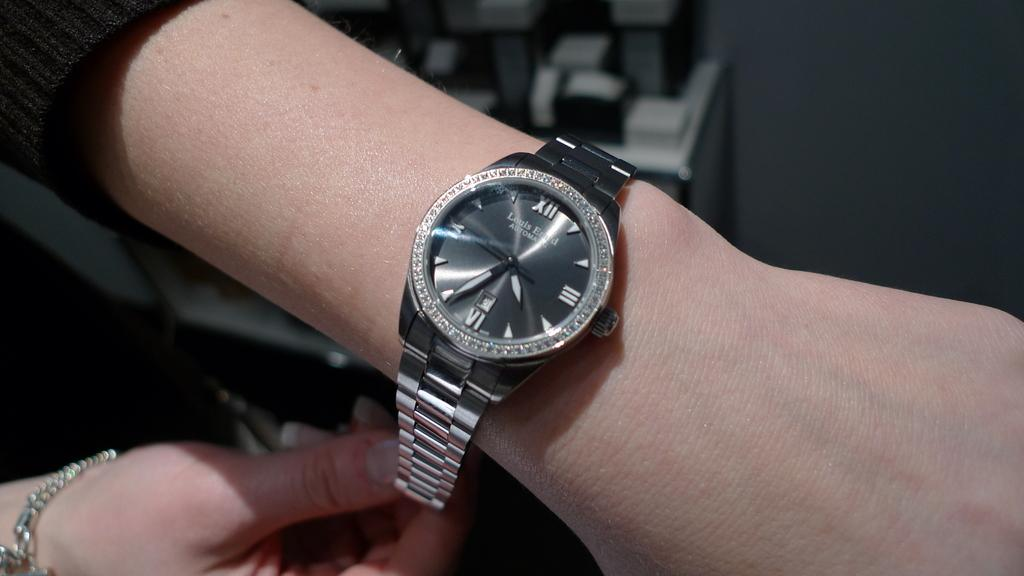<image>
Present a compact description of the photo's key features. The watch on the woman's left wrist says that it is nearly 4:35. 